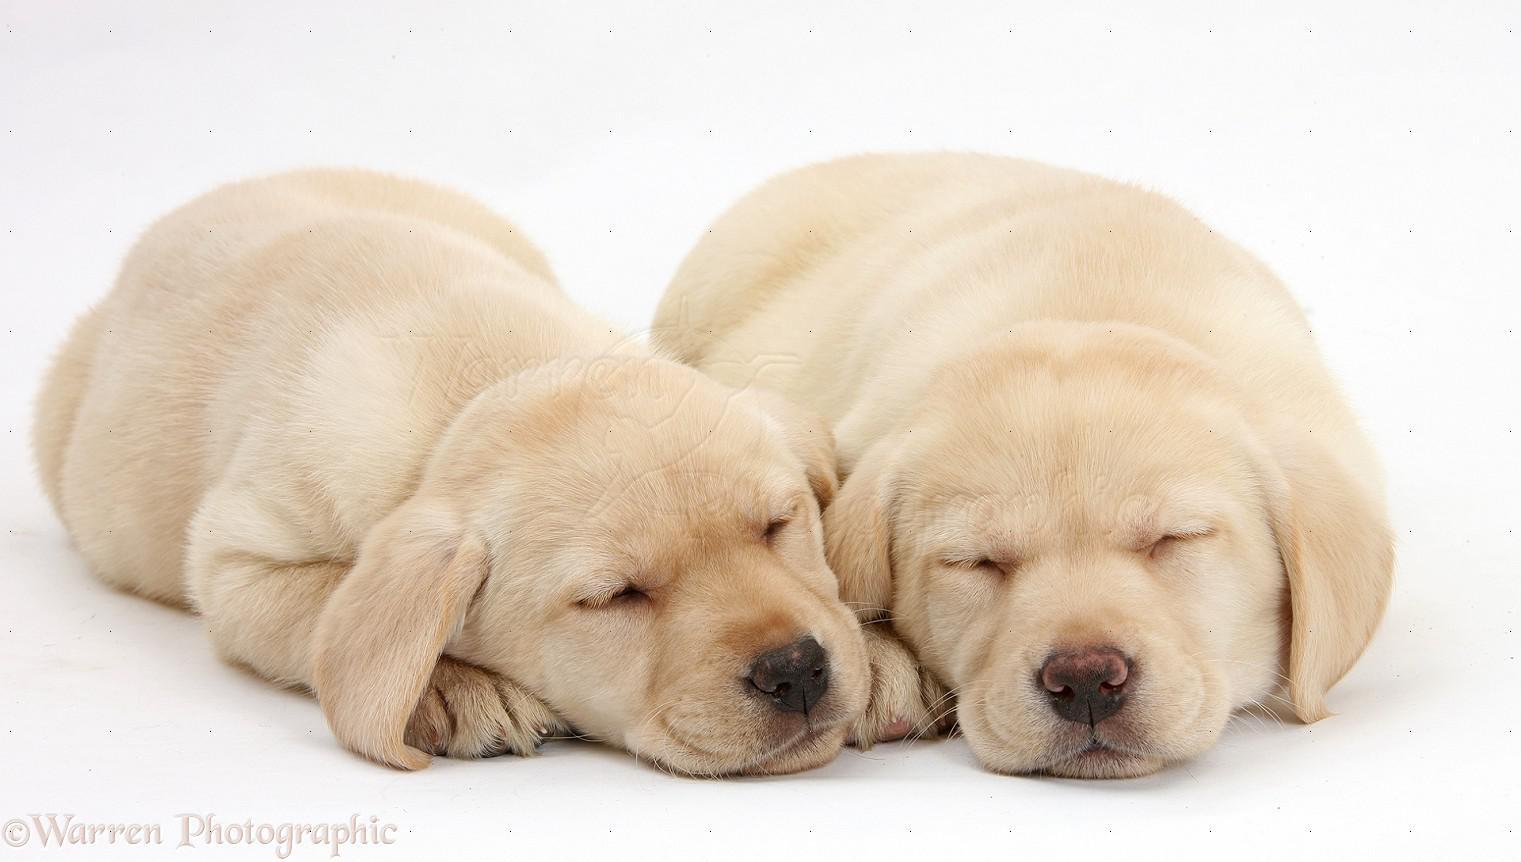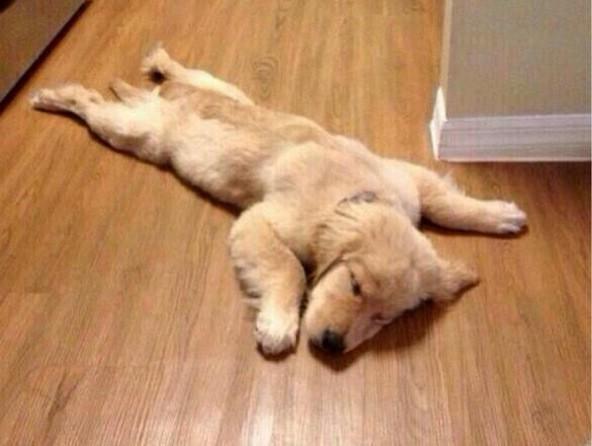The first image is the image on the left, the second image is the image on the right. Given the left and right images, does the statement "Two dogs of similar coloring are snoozing with heads touching on a wood-grained surface." hold true? Answer yes or no. No. The first image is the image on the left, the second image is the image on the right. Assess this claim about the two images: "some dogs are sleeping and some are not.". Correct or not? Answer yes or no. No. 